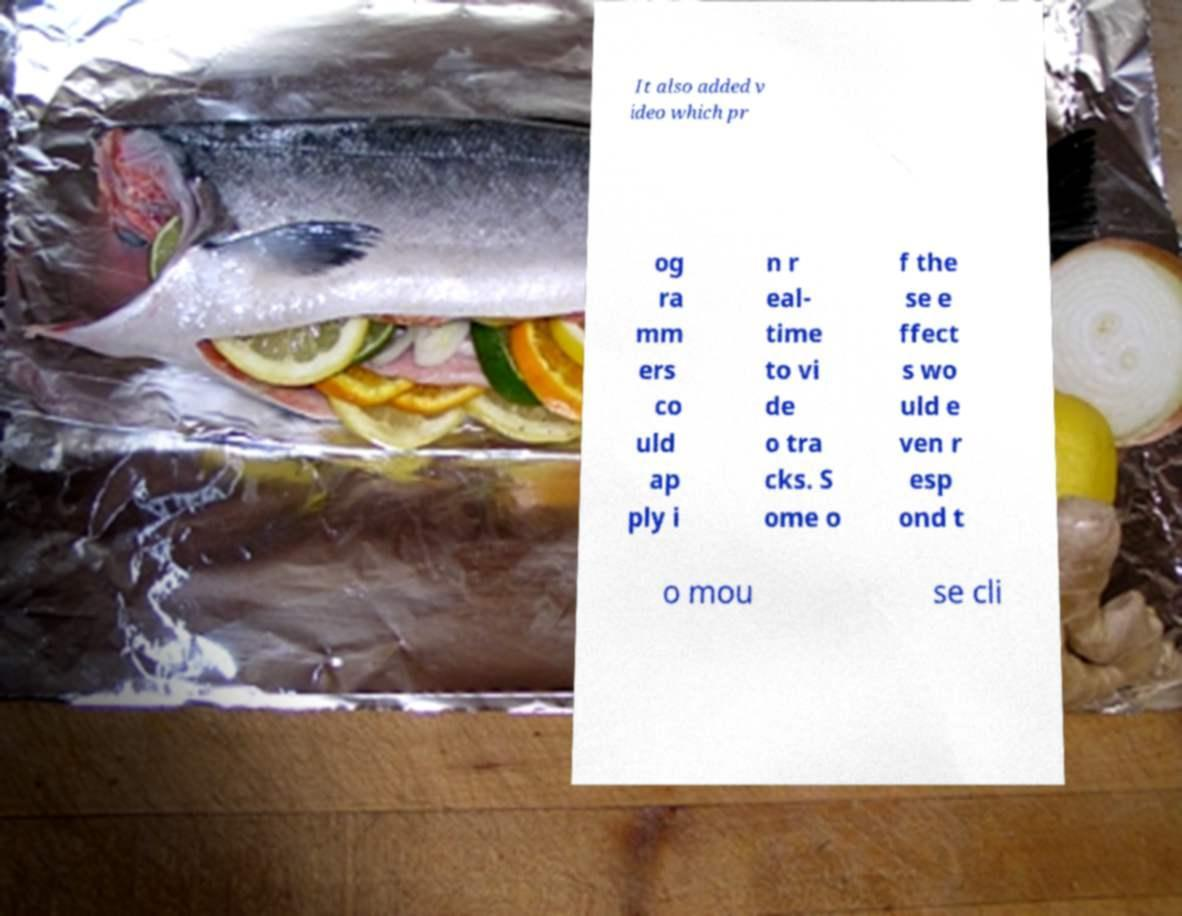Could you assist in decoding the text presented in this image and type it out clearly? It also added v ideo which pr og ra mm ers co uld ap ply i n r eal- time to vi de o tra cks. S ome o f the se e ffect s wo uld e ven r esp ond t o mou se cli 